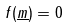Convert formula to latex. <formula><loc_0><loc_0><loc_500><loc_500>f ( \underline { m } ) = 0</formula> 